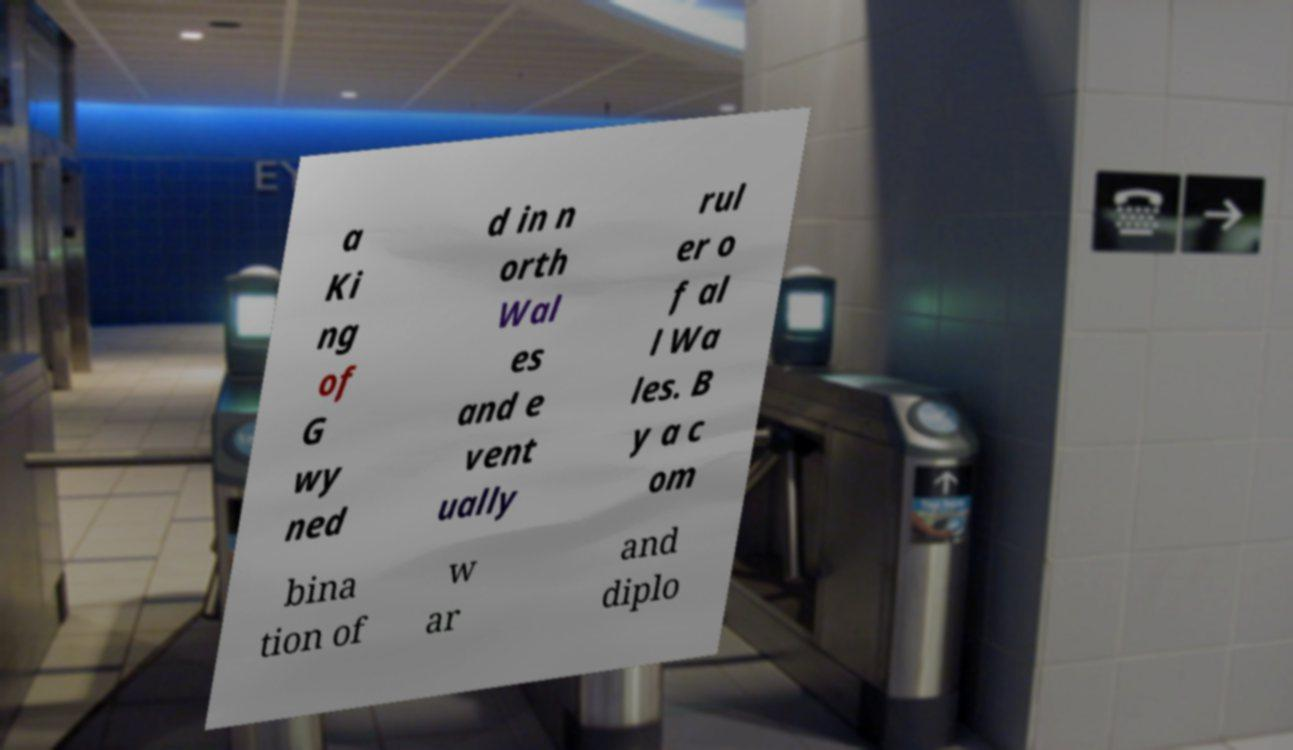Could you extract and type out the text from this image? a Ki ng of G wy ned d in n orth Wal es and e vent ually rul er o f al l Wa les. B y a c om bina tion of w ar and diplo 